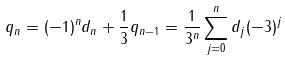<formula> <loc_0><loc_0><loc_500><loc_500>q _ { n } = ( - 1 ) ^ { n } d _ { n } + \frac { 1 } { 3 } q _ { n - 1 } = \frac { 1 } { 3 ^ { n } } \sum _ { j = 0 } ^ { n } d _ { j } ( - 3 ) ^ { j }</formula> 